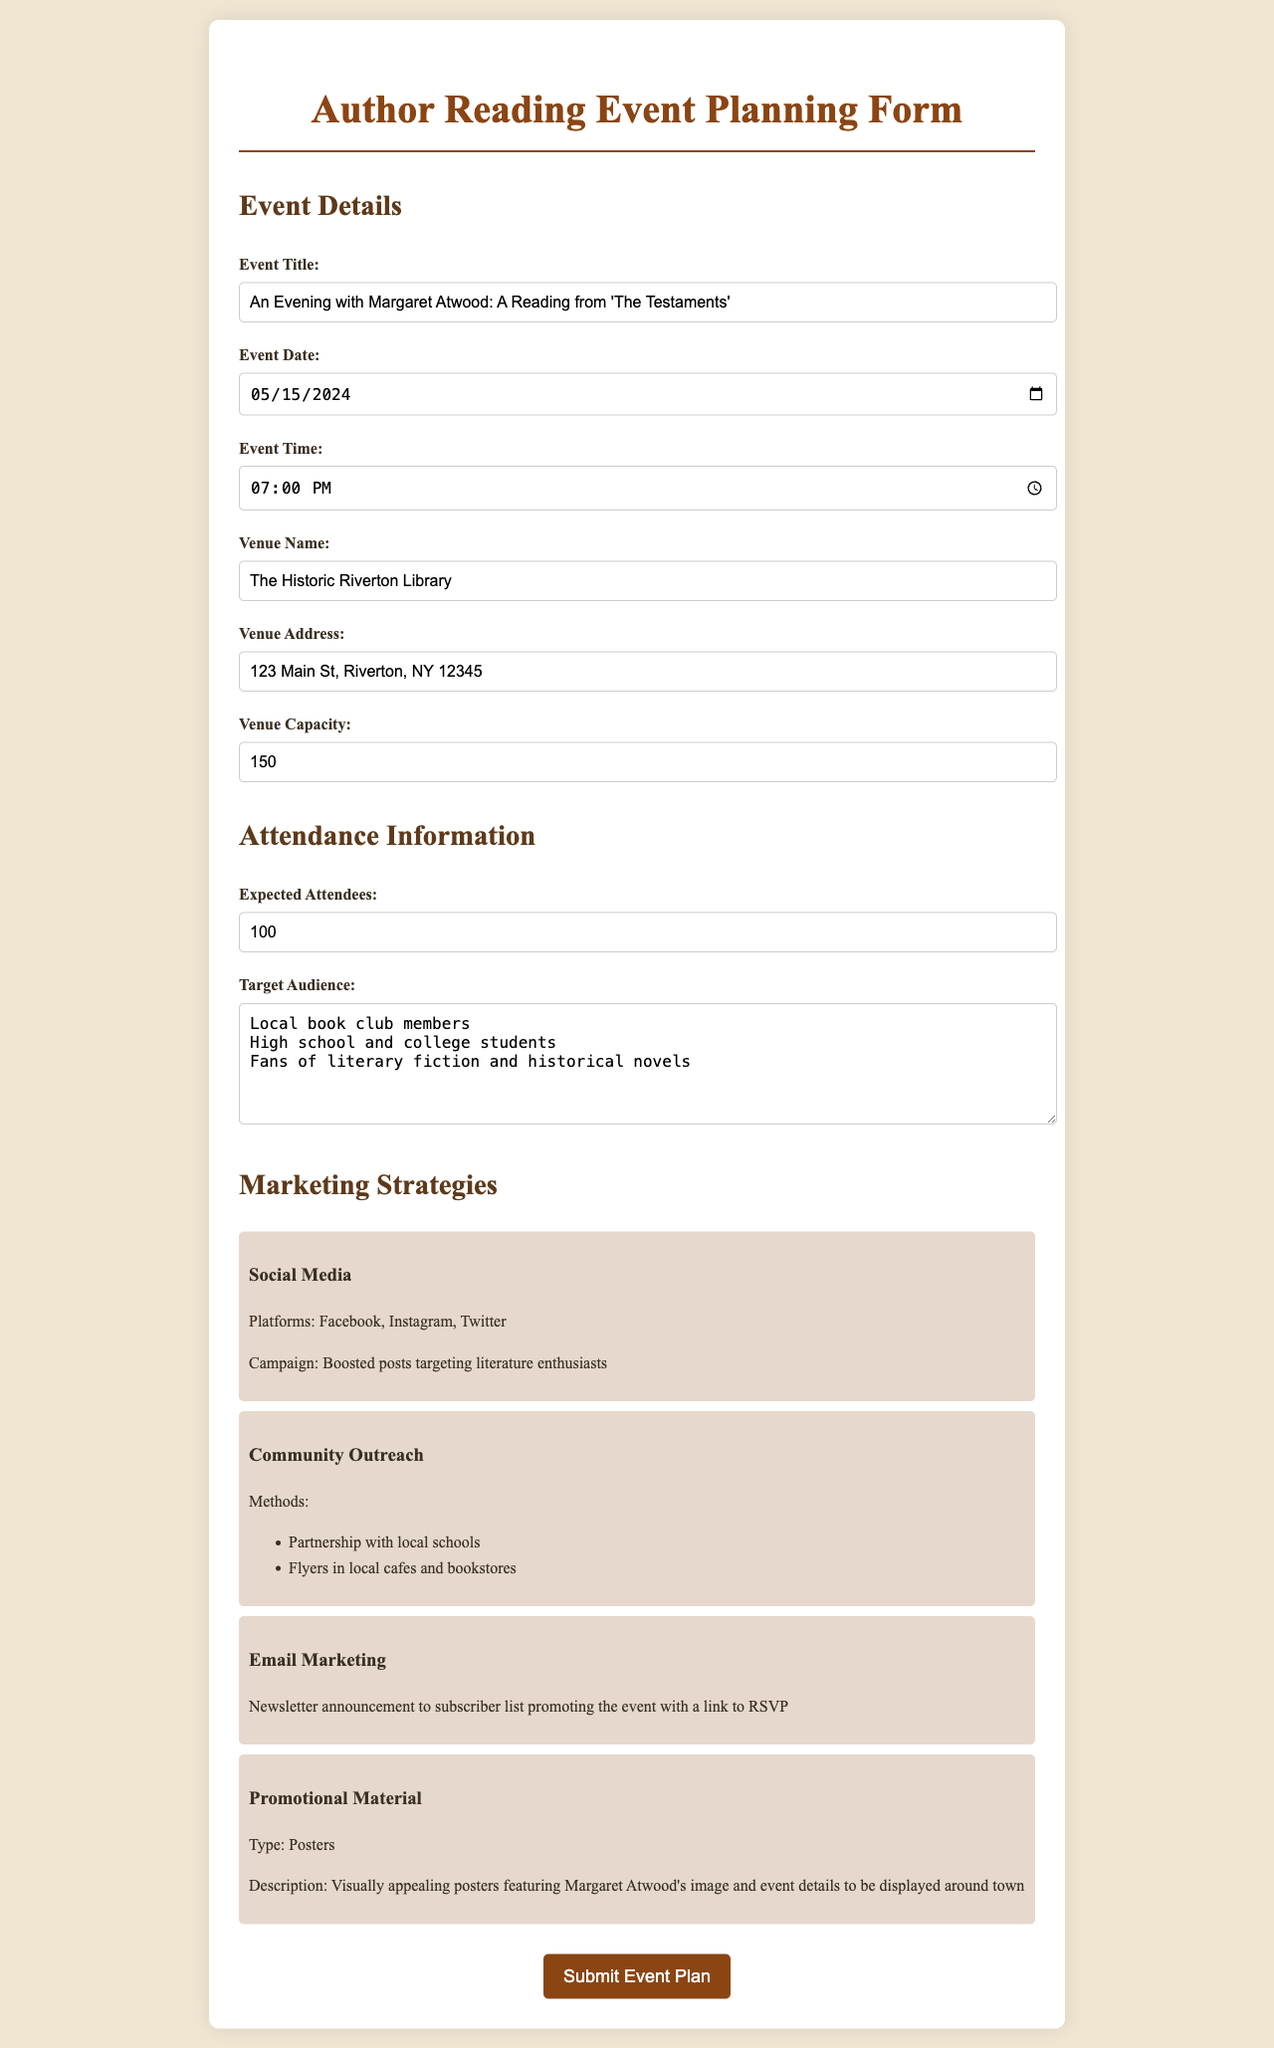What is the event title? The event title is specified in the document under "Event Title" section.
Answer: An Evening with Margaret Atwood: A Reading from 'The Testaments' What is the event date? The date of the event is mentioned in the "Event Date" field of the document.
Answer: 2024-05-15 What is the venue name? The document provides the venue name in the "Venue Name" section.
Answer: The Historic Riverton Library What is the expected number of attendees? The expected attendees are listed in the "Expected Attendees" field in the document.
Answer: 100 What is the target audience mentioned? The target audience is included in the "Target Audience" section of the form.
Answer: Local book club members, High school and college students, Fans of literary fiction and historical novels Which social media platforms are used in the marketing strategies? The social media platforms are listed in the "Social Media" strategy section of the document.
Answer: Facebook, Instagram, Twitter What is one method of community outreach? Community outreach methods are outlined in the "Community Outreach" strategy section of the form.
Answer: Partnership with local schools What type of promotional material is mentioned? The type of promotional material can be found in the "Promotional Material" strategy section.
Answer: Posters What is the venue capacity? The venue capacity is indicated in the "Venue Capacity" field of the document.
Answer: 150 What time does the event start? The starting time of the event is detailed in the "Event Time" section.
Answer: 19:00 